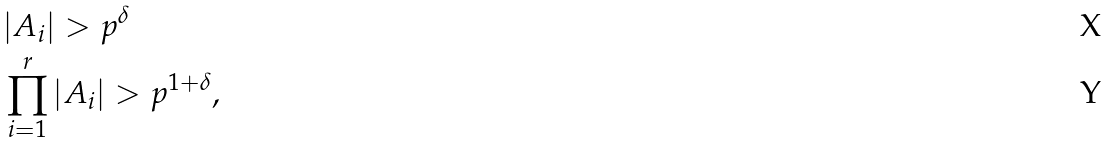Convert formula to latex. <formula><loc_0><loc_0><loc_500><loc_500>& | A _ { i } | > p ^ { \delta } \\ & \prod _ { i = 1 } ^ { r } | A _ { i } | > p ^ { 1 + \delta } ,</formula> 